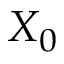<formula> <loc_0><loc_0><loc_500><loc_500>X _ { 0 }</formula> 